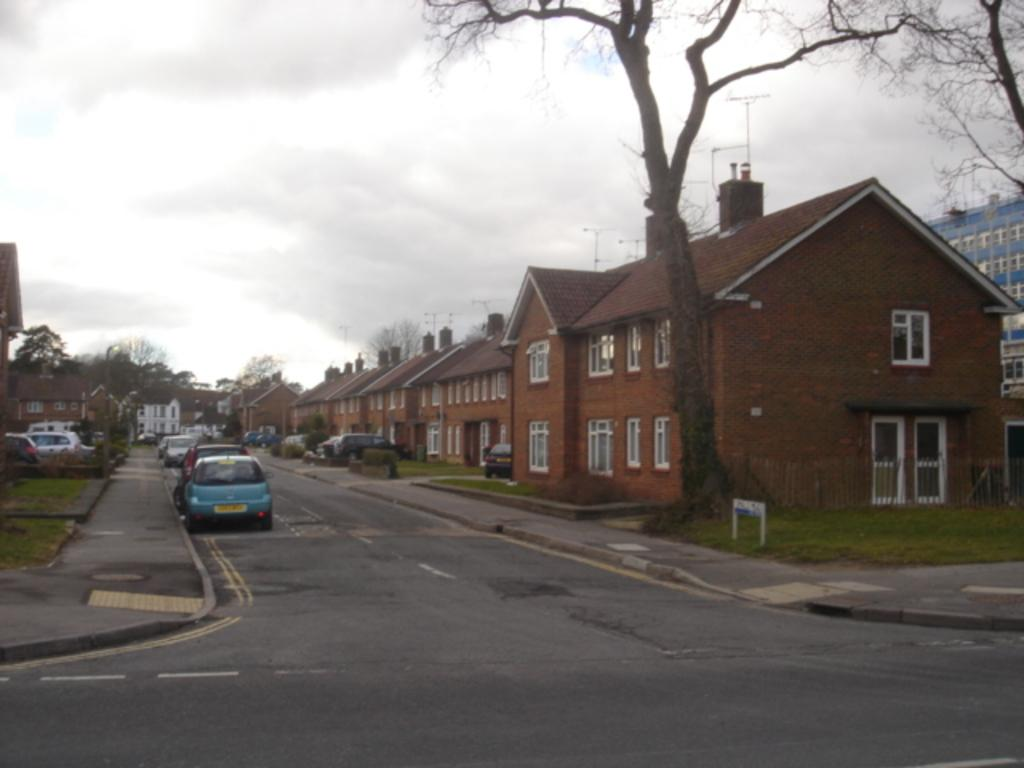What type of structures can be seen in the image? There are many houses in the image. What features do the houses have? The houses have windows and doors. What type of vegetation is present in the image? There are trees in the image. What type of vehicles can be seen in the image? There are cars on the road in the image. What type of ground cover is visible in the image? There is grass visible in the image. What is the condition of the sky in the image? The sky is cloudy in the image. What type of skirt is the grandfather wearing in the image? There is no grandfather or skirt present in the image. What type of alarm is going off in the image? There is no alarm present in the image. 